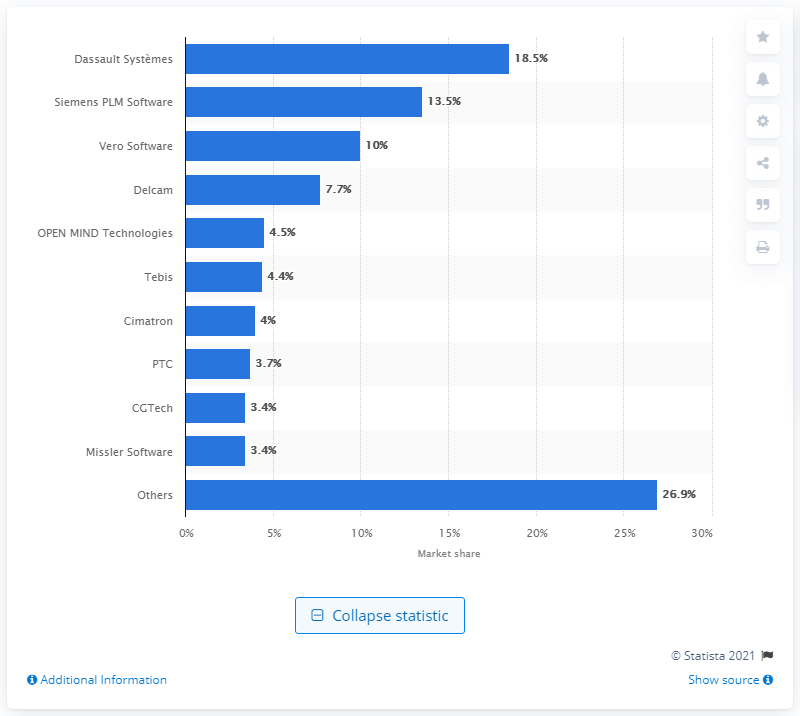Point out several critical features in this image. In 2013, the global market share of Dassault Syst mes in the NC software market was 18.5%. 